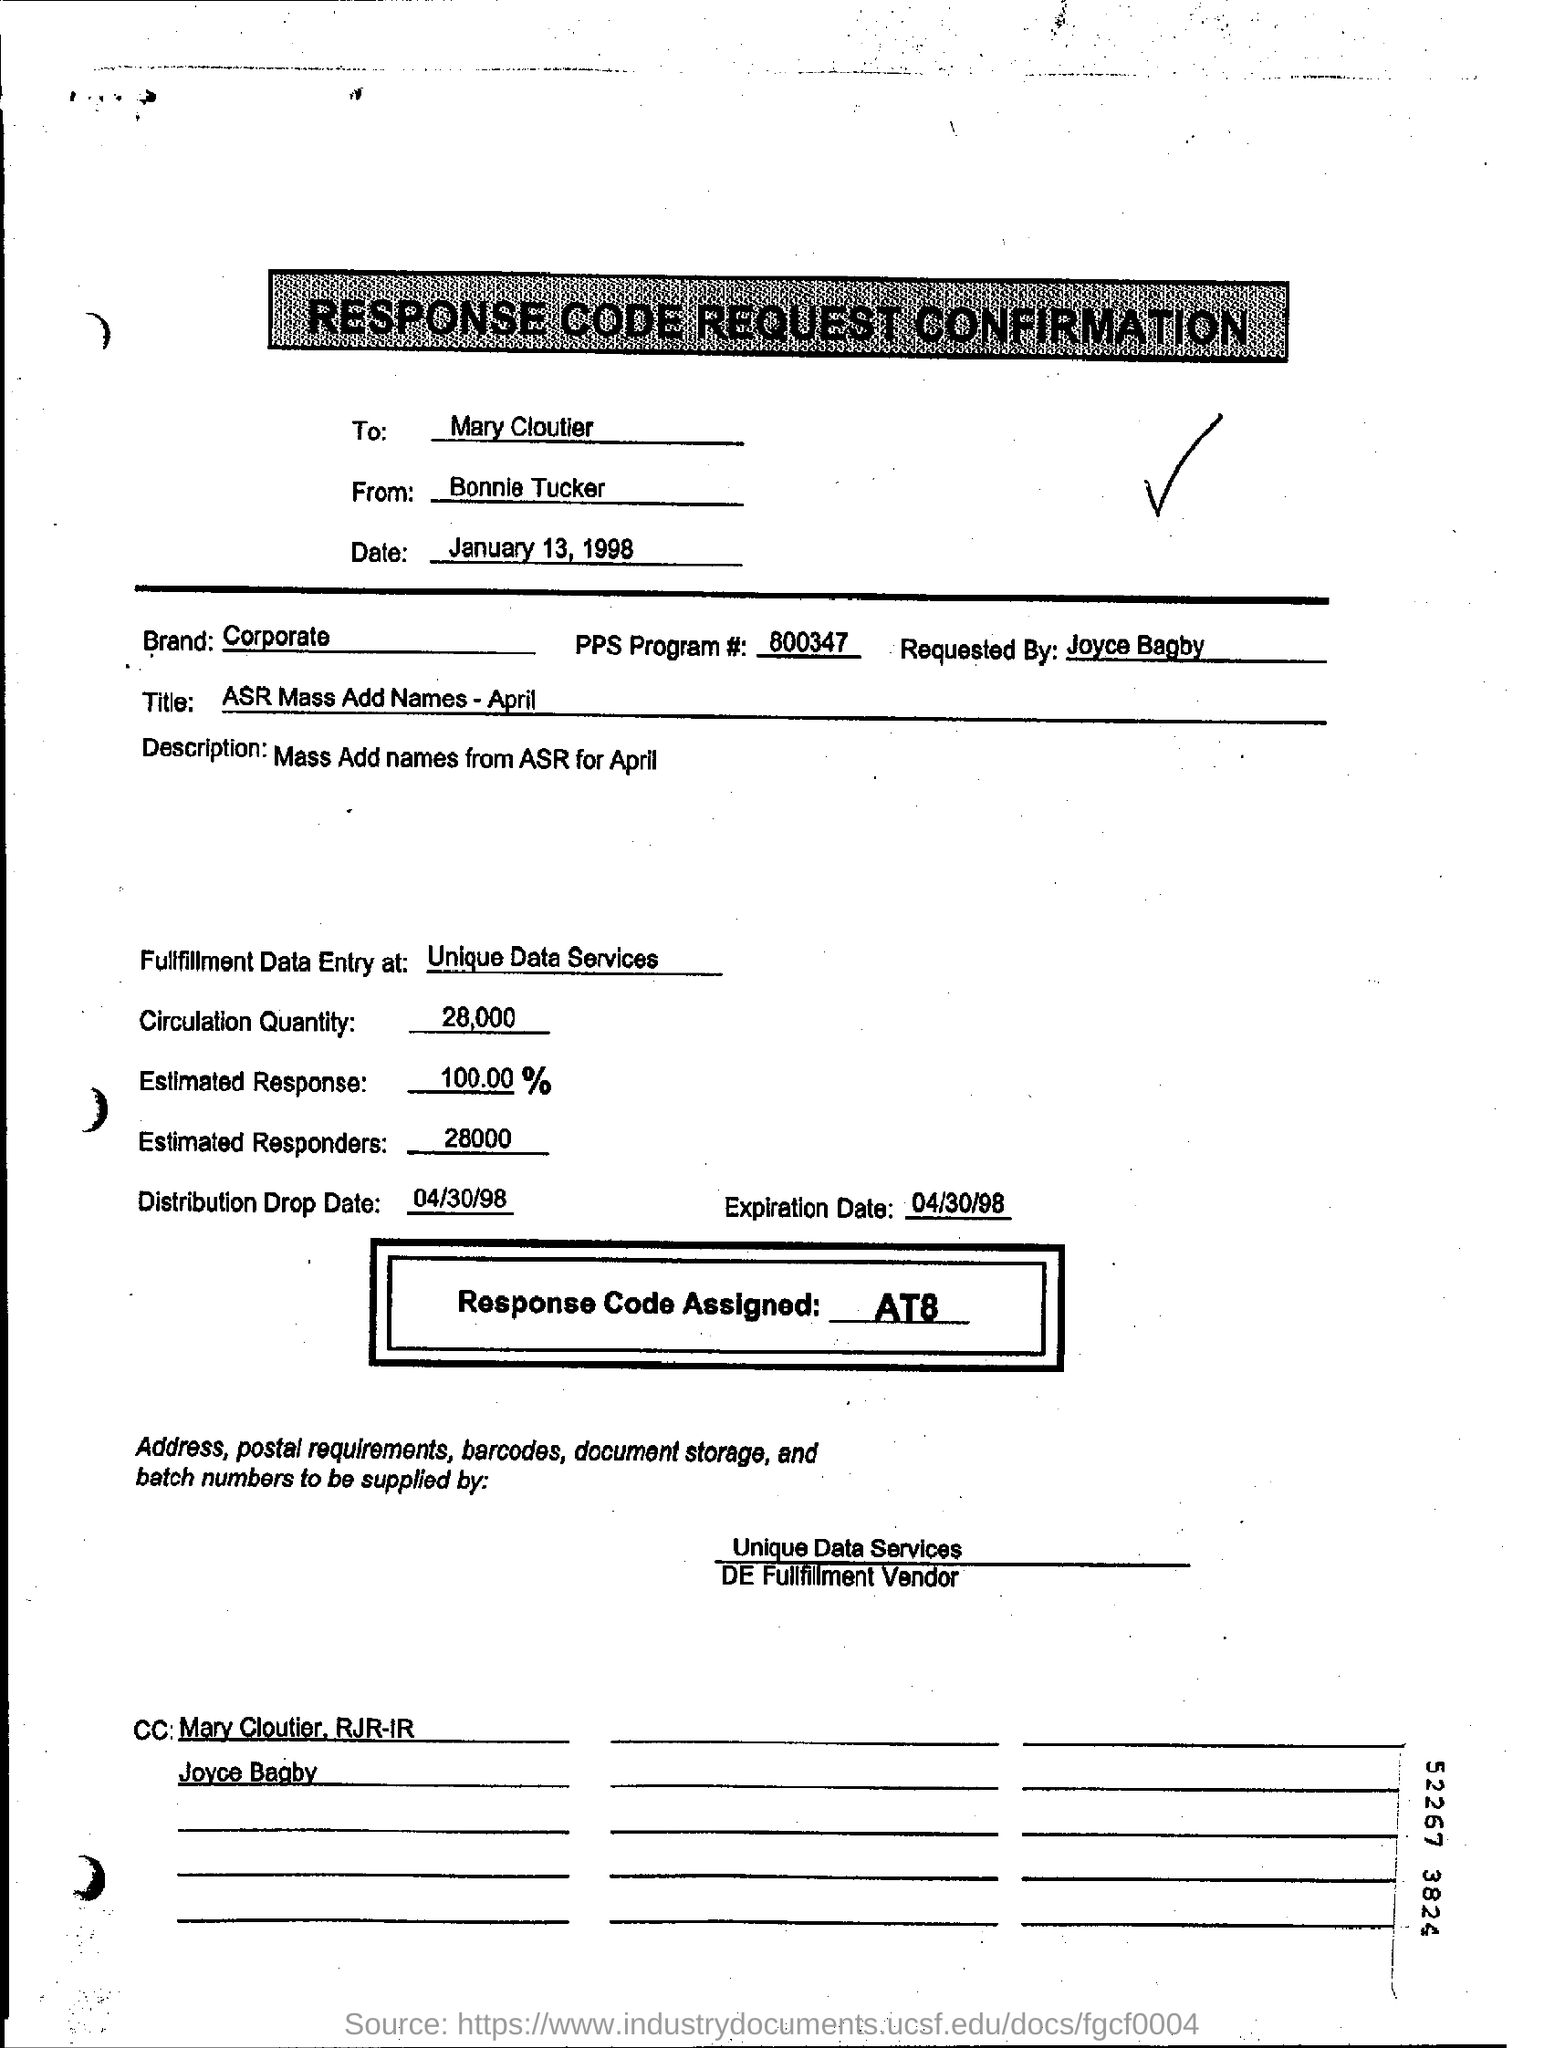What is the significance of the response code 'AT8' highlighted in this document? The 'AT8' code in the document stands as a unique identifier or reference for the particular request or transaction outlined in the document. It's likely used to track the process or response of this specific action within the organization or the database. Could this type of document be relevant today, or is it outdated? While the specific format of this document may appear outdated due to its reference to 1998, similar types of documents and processes are still relevant today. Organizations often use structured forms and codes for various operations, like data entry, distribution of materials, and record-keeping, although the technology might have evolved. 